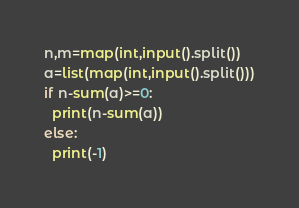Convert code to text. <code><loc_0><loc_0><loc_500><loc_500><_Python_>n,m=map(int,input().split())
a=list(map(int,input().split()))
if n-sum(a)>=0:
  print(n-sum(a))
else:
  print(-1)</code> 